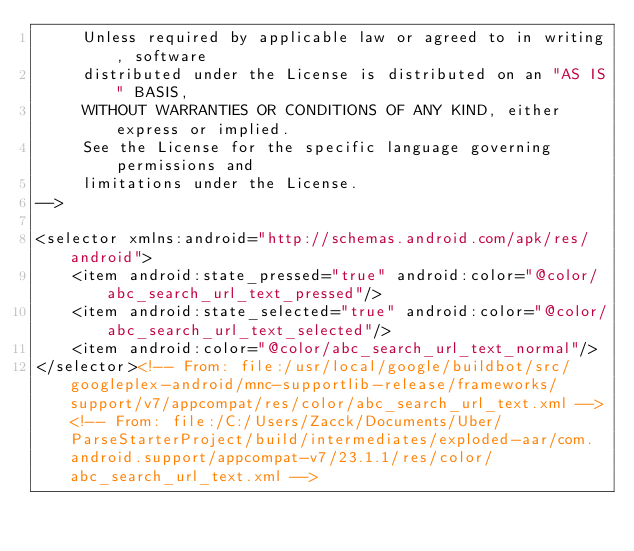Convert code to text. <code><loc_0><loc_0><loc_500><loc_500><_XML_>     Unless required by applicable law or agreed to in writing, software
     distributed under the License is distributed on an "AS IS" BASIS,
     WITHOUT WARRANTIES OR CONDITIONS OF ANY KIND, either express or implied.
     See the License for the specific language governing permissions and
     limitations under the License.
-->

<selector xmlns:android="http://schemas.android.com/apk/res/android">
    <item android:state_pressed="true" android:color="@color/abc_search_url_text_pressed"/>
    <item android:state_selected="true" android:color="@color/abc_search_url_text_selected"/>
    <item android:color="@color/abc_search_url_text_normal"/>
</selector><!-- From: file:/usr/local/google/buildbot/src/googleplex-android/mnc-supportlib-release/frameworks/support/v7/appcompat/res/color/abc_search_url_text.xml --><!-- From: file:/C:/Users/Zacck/Documents/Uber/ParseStarterProject/build/intermediates/exploded-aar/com.android.support/appcompat-v7/23.1.1/res/color/abc_search_url_text.xml --></code> 